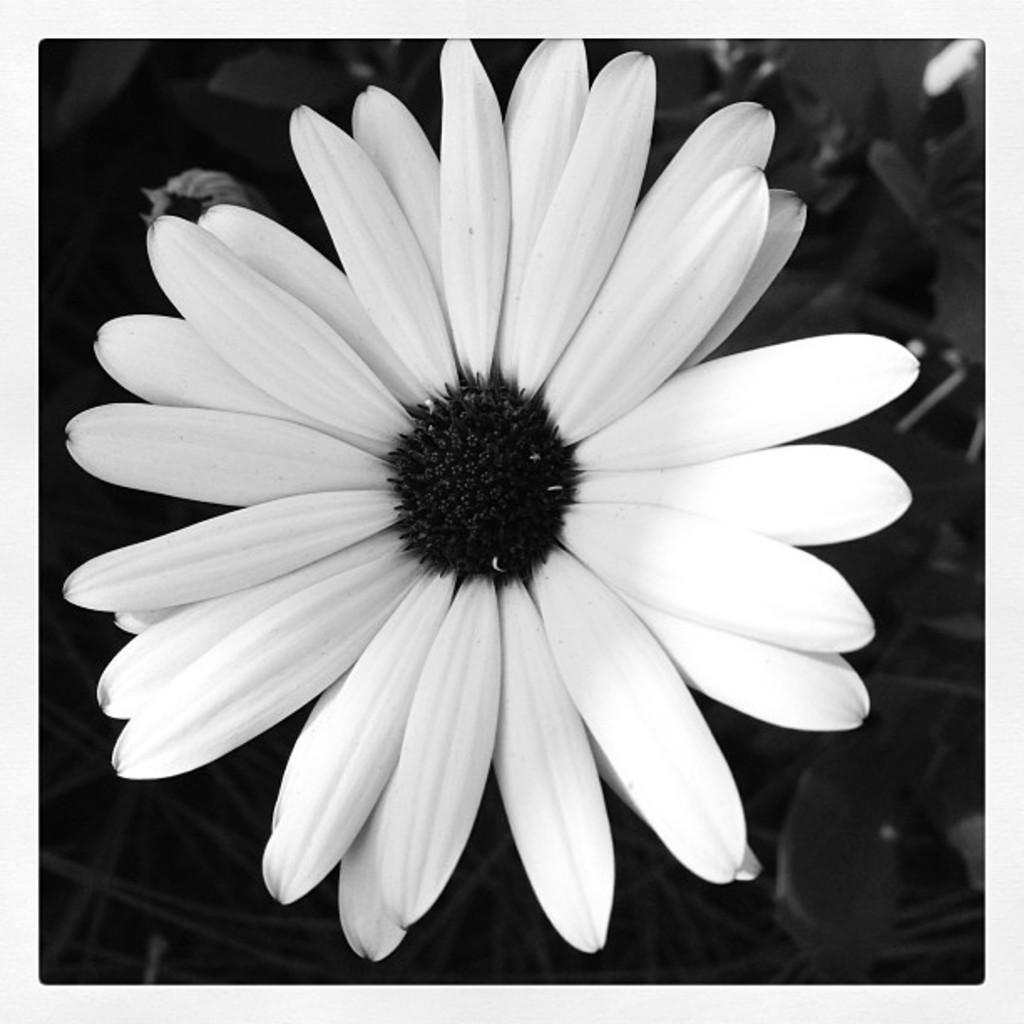In one or two sentences, can you explain what this image depicts? In the image I can see a plant to which there is a flower which is in white color. 